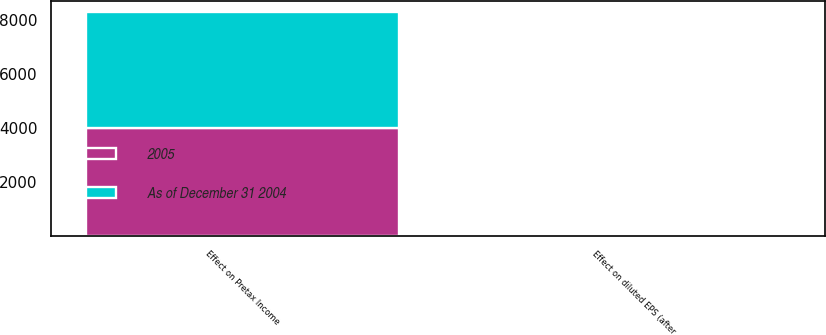<chart> <loc_0><loc_0><loc_500><loc_500><stacked_bar_chart><ecel><fcel>Effect on Pretax Income<fcel>Effect on diluted EPS (after<nl><fcel>As of December 31 2004<fcel>4287<fcel>0.04<nl><fcel>2005<fcel>4006<fcel>0.04<nl></chart> 